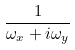Convert formula to latex. <formula><loc_0><loc_0><loc_500><loc_500>\frac { 1 } { \omega _ { x } + i \omega _ { y } }</formula> 